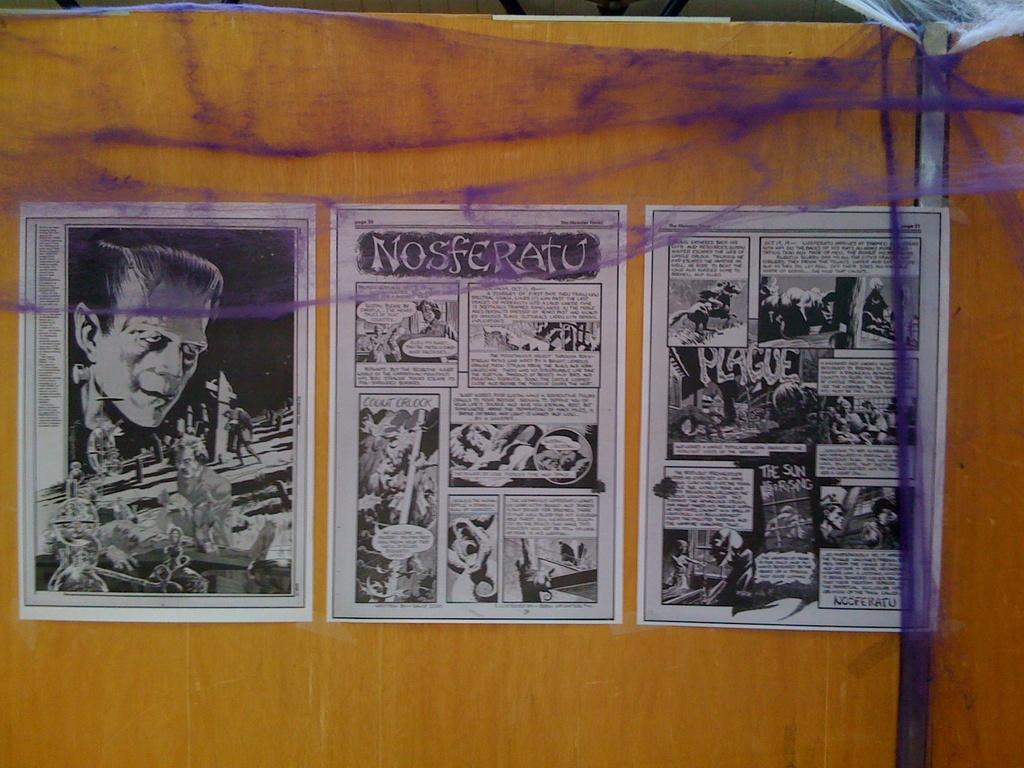What is the name of the story on the second page?
Provide a short and direct response. Nosferatu. Is there a panel about the plague?
Make the answer very short. Yes. 